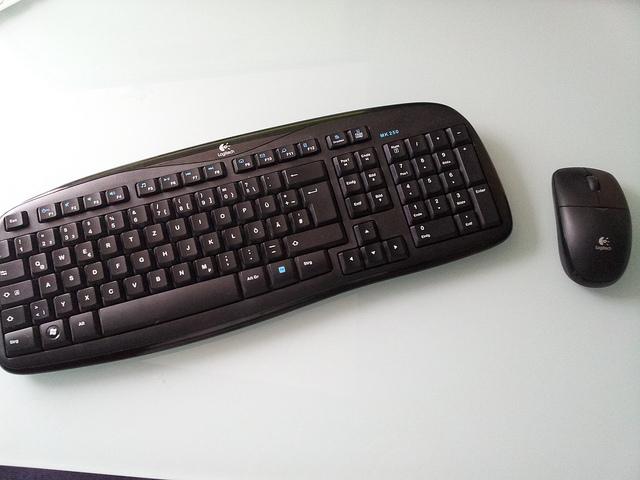What color do the mouse and keyboard have in common?
Be succinct. Black. Does the mouse have a cord?
Short answer required. No. Does this keyboard have a ten key?
Be succinct. Yes. Is the keyboard clean?
Be succinct. Yes. Do the brands match?
Answer briefly. Yes. 